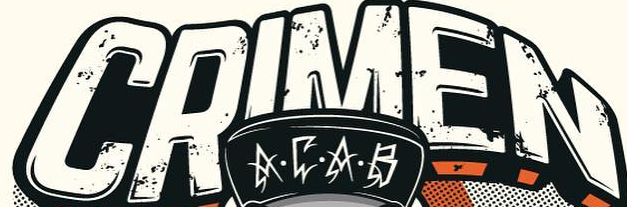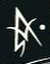What text appears in these images from left to right, separated by a semicolon? CRIMEN; A 